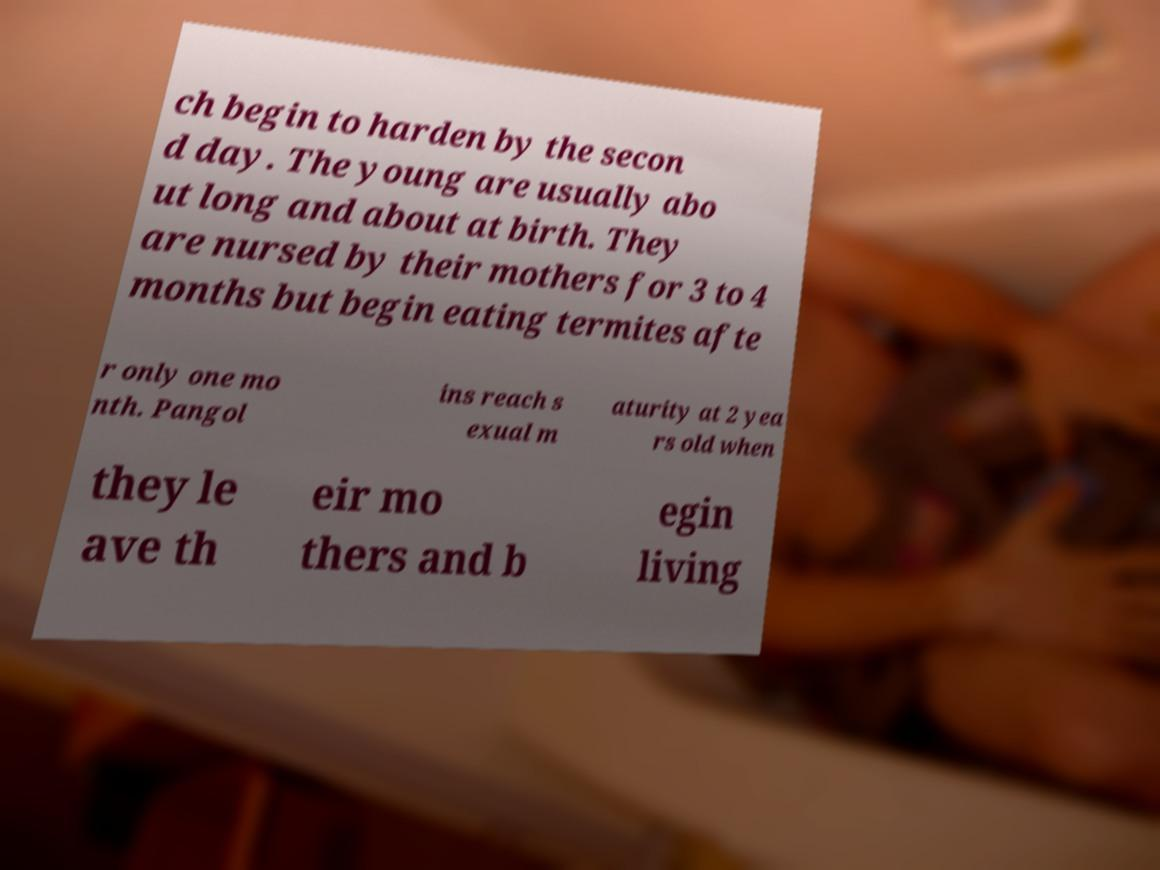Please identify and transcribe the text found in this image. ch begin to harden by the secon d day. The young are usually abo ut long and about at birth. They are nursed by their mothers for 3 to 4 months but begin eating termites afte r only one mo nth. Pangol ins reach s exual m aturity at 2 yea rs old when they le ave th eir mo thers and b egin living 